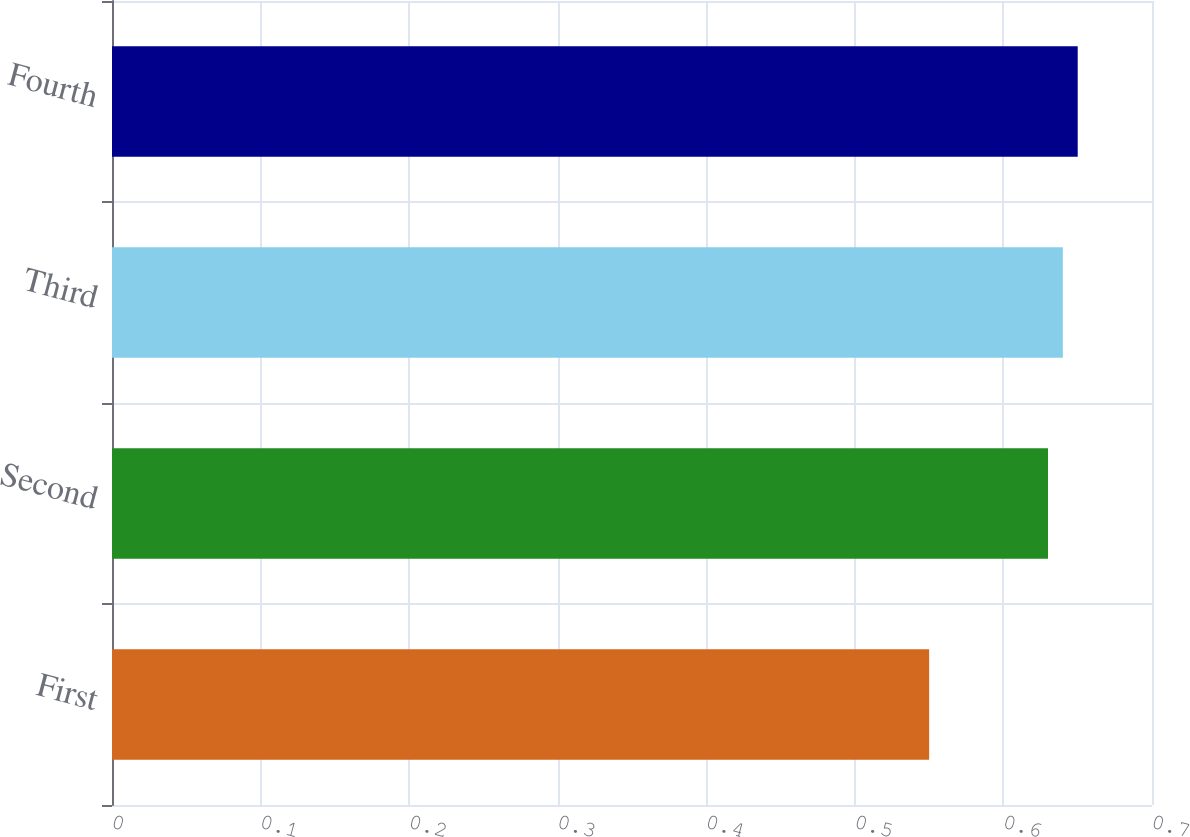Convert chart. <chart><loc_0><loc_0><loc_500><loc_500><bar_chart><fcel>First<fcel>Second<fcel>Third<fcel>Fourth<nl><fcel>0.55<fcel>0.63<fcel>0.64<fcel>0.65<nl></chart> 